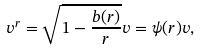<formula> <loc_0><loc_0><loc_500><loc_500>v ^ { r } = \sqrt { 1 - \frac { b ( r ) } { r } } v = \psi ( r ) v ,</formula> 